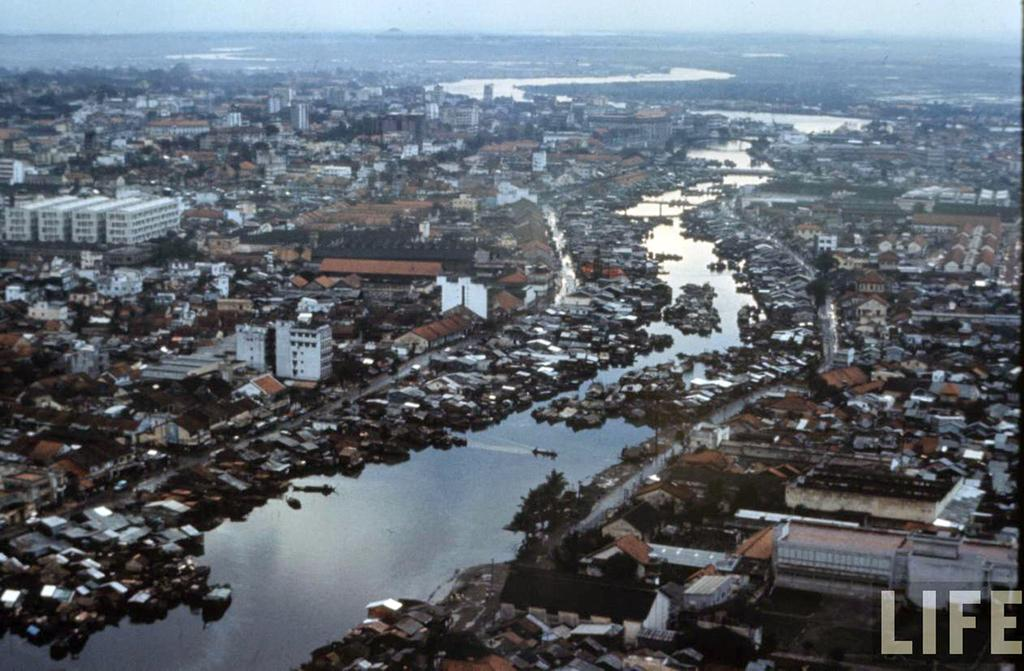What type of view is shown in the image? The image is an aerial view of a city. What structures can be seen in the image? There are buildings and houses in the image. Is there any natural feature visible in the image? Yes, there is a river visible in the image. Can you see any feathers floating in the river in the image? There are no feathers visible in the image, as it is an aerial view of a city with a focus on buildings, houses, and a river. 